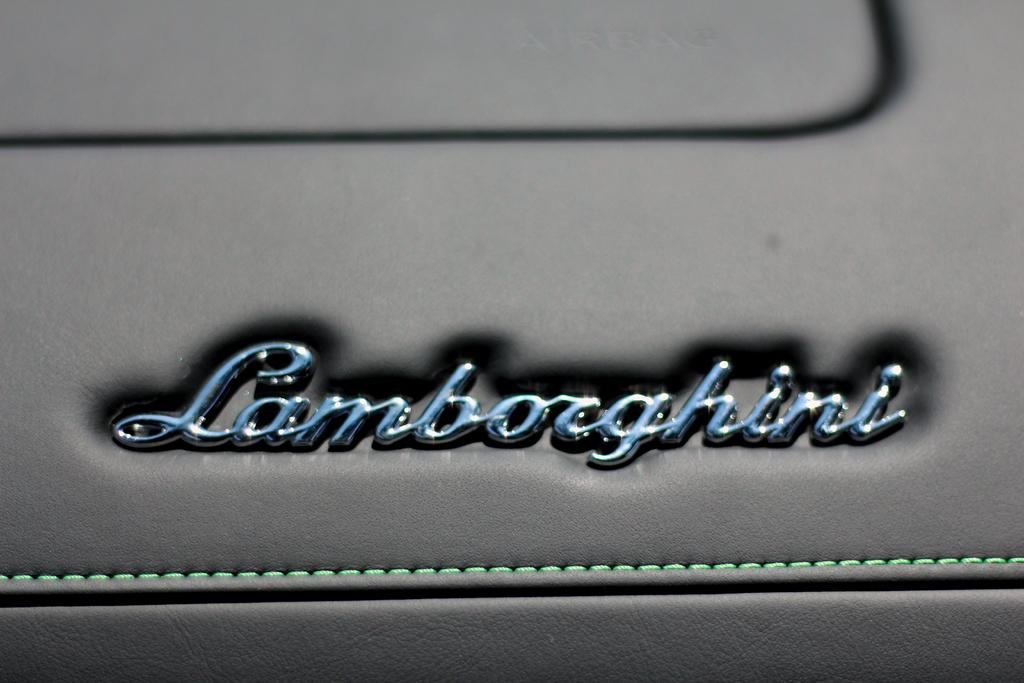What word is written on the leather sheet in the image? The word "Lamborghini" is written on a leather sheet in the image. How many pets are visible in the image? There are no pets visible in the image; it only features the word "Lamborghini" written on a leather sheet. 